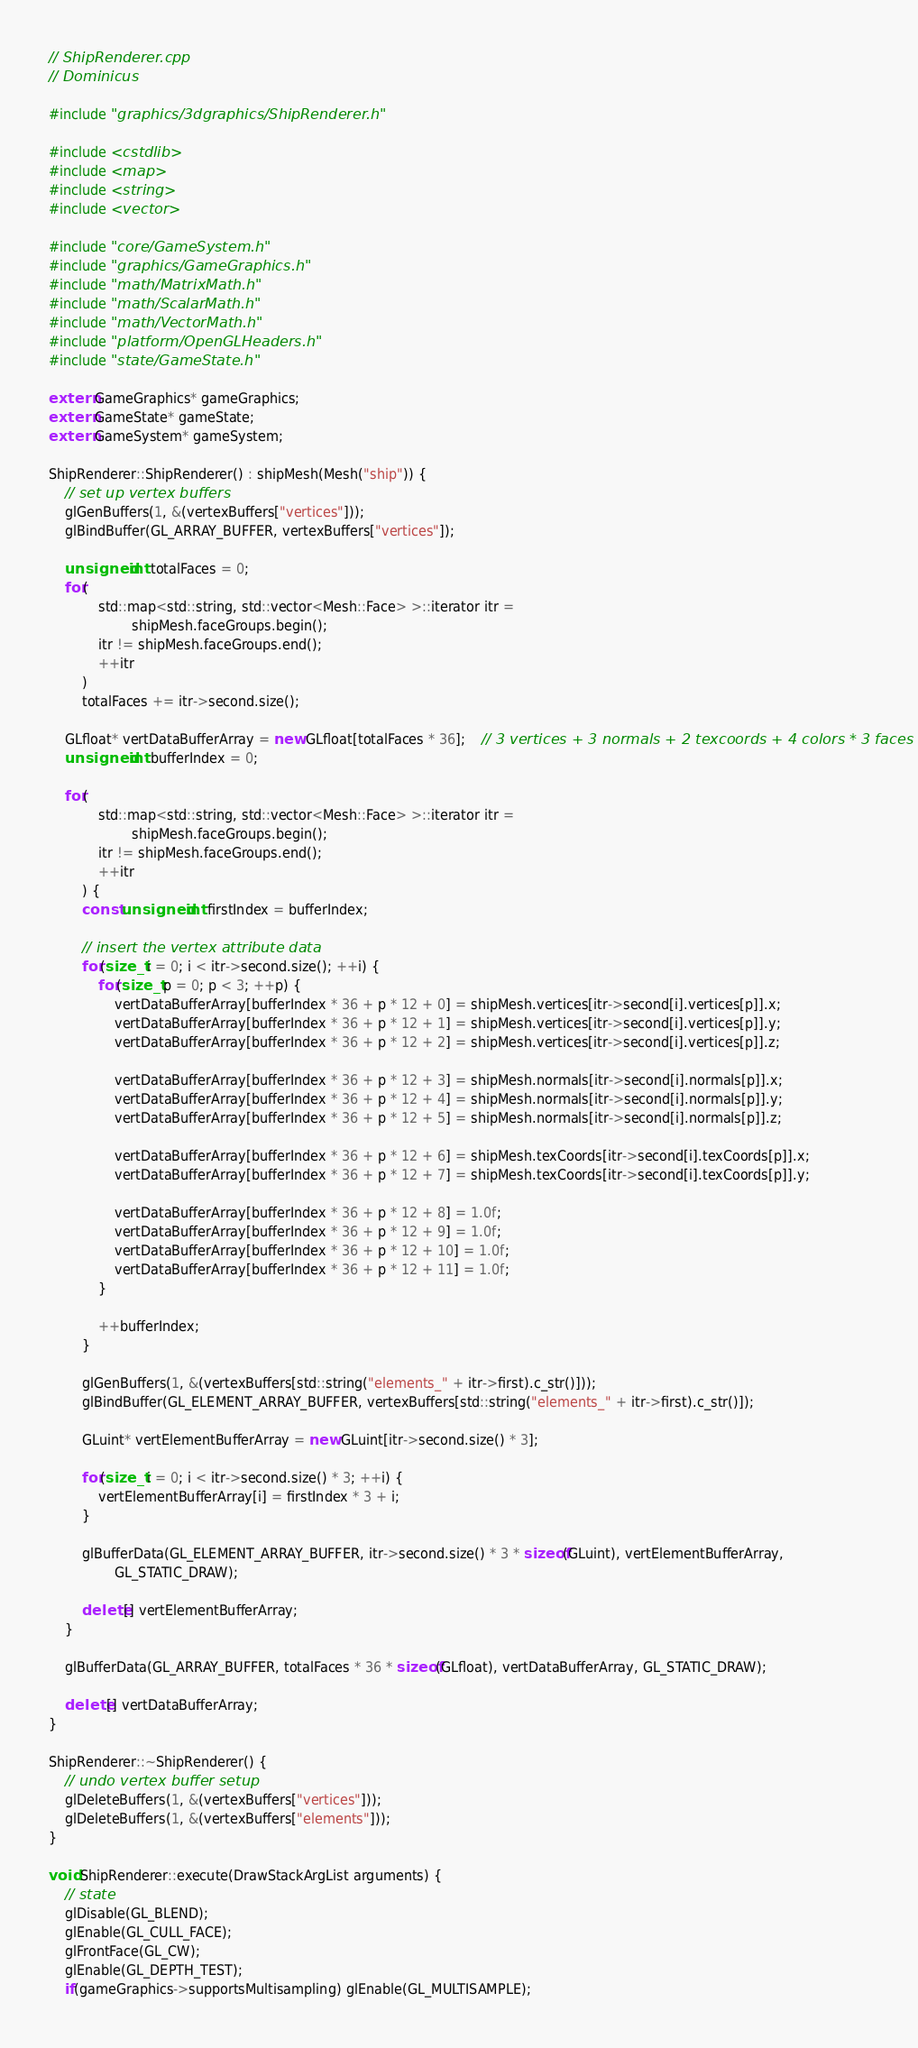<code> <loc_0><loc_0><loc_500><loc_500><_C++_>// ShipRenderer.cpp
// Dominicus

#include "graphics/3dgraphics/ShipRenderer.h"

#include <cstdlib>
#include <map>
#include <string>
#include <vector>

#include "core/GameSystem.h"
#include "graphics/GameGraphics.h"
#include "math/MatrixMath.h"
#include "math/ScalarMath.h"
#include "math/VectorMath.h"
#include "platform/OpenGLHeaders.h"
#include "state/GameState.h"

extern GameGraphics* gameGraphics;
extern GameState* gameState;
extern GameSystem* gameSystem;

ShipRenderer::ShipRenderer() : shipMesh(Mesh("ship")) {
	// set up vertex buffers
	glGenBuffers(1, &(vertexBuffers["vertices"]));
	glBindBuffer(GL_ARRAY_BUFFER, vertexBuffers["vertices"]);

	unsigned int totalFaces = 0;
	for(
			std::map<std::string, std::vector<Mesh::Face> >::iterator itr =
					shipMesh.faceGroups.begin();
			itr != shipMesh.faceGroups.end();
			++itr
		)
		totalFaces += itr->second.size();

	GLfloat* vertDataBufferArray = new GLfloat[totalFaces * 36];	// 3 vertices + 3 normals + 2 texcoords + 4 colors * 3 faces
	unsigned int bufferIndex = 0;

	for(
			std::map<std::string, std::vector<Mesh::Face> >::iterator itr =
					shipMesh.faceGroups.begin();
			itr != shipMesh.faceGroups.end();
			++itr
		) {
		const unsigned int firstIndex = bufferIndex;

		// insert the vertex attribute data
		for(size_t i = 0; i < itr->second.size(); ++i) {
			for(size_t p = 0; p < 3; ++p) {
				vertDataBufferArray[bufferIndex * 36 + p * 12 + 0] = shipMesh.vertices[itr->second[i].vertices[p]].x;
				vertDataBufferArray[bufferIndex * 36 + p * 12 + 1] = shipMesh.vertices[itr->second[i].vertices[p]].y;
				vertDataBufferArray[bufferIndex * 36 + p * 12 + 2] = shipMesh.vertices[itr->second[i].vertices[p]].z;

				vertDataBufferArray[bufferIndex * 36 + p * 12 + 3] = shipMesh.normals[itr->second[i].normals[p]].x;
				vertDataBufferArray[bufferIndex * 36 + p * 12 + 4] = shipMesh.normals[itr->second[i].normals[p]].y;
				vertDataBufferArray[bufferIndex * 36 + p * 12 + 5] = shipMesh.normals[itr->second[i].normals[p]].z;

				vertDataBufferArray[bufferIndex * 36 + p * 12 + 6] = shipMesh.texCoords[itr->second[i].texCoords[p]].x;
				vertDataBufferArray[bufferIndex * 36 + p * 12 + 7] = shipMesh.texCoords[itr->second[i].texCoords[p]].y;

				vertDataBufferArray[bufferIndex * 36 + p * 12 + 8] = 1.0f;
				vertDataBufferArray[bufferIndex * 36 + p * 12 + 9] = 1.0f;
				vertDataBufferArray[bufferIndex * 36 + p * 12 + 10] = 1.0f;
				vertDataBufferArray[bufferIndex * 36 + p * 12 + 11] = 1.0f;
			}

			++bufferIndex;
		}

		glGenBuffers(1, &(vertexBuffers[std::string("elements_" + itr->first).c_str()]));
		glBindBuffer(GL_ELEMENT_ARRAY_BUFFER, vertexBuffers[std::string("elements_" + itr->first).c_str()]);

		GLuint* vertElementBufferArray = new GLuint[itr->second.size() * 3];

		for(size_t i = 0; i < itr->second.size() * 3; ++i) {
			vertElementBufferArray[i] = firstIndex * 3 + i;
		}

		glBufferData(GL_ELEMENT_ARRAY_BUFFER, itr->second.size() * 3 * sizeof(GLuint), vertElementBufferArray,
				GL_STATIC_DRAW);

		delete[] vertElementBufferArray;
	}

	glBufferData(GL_ARRAY_BUFFER, totalFaces * 36 * sizeof(GLfloat), vertDataBufferArray, GL_STATIC_DRAW);

	delete[] vertDataBufferArray;
}

ShipRenderer::~ShipRenderer() {
	// undo vertex buffer setup
	glDeleteBuffers(1, &(vertexBuffers["vertices"]));
	glDeleteBuffers(1, &(vertexBuffers["elements"]));
}

void ShipRenderer::execute(DrawStackArgList arguments) {
	// state
	glDisable(GL_BLEND);
	glEnable(GL_CULL_FACE);
	glFrontFace(GL_CW);
	glEnable(GL_DEPTH_TEST);
	if(gameGraphics->supportsMultisampling) glEnable(GL_MULTISAMPLE);</code> 